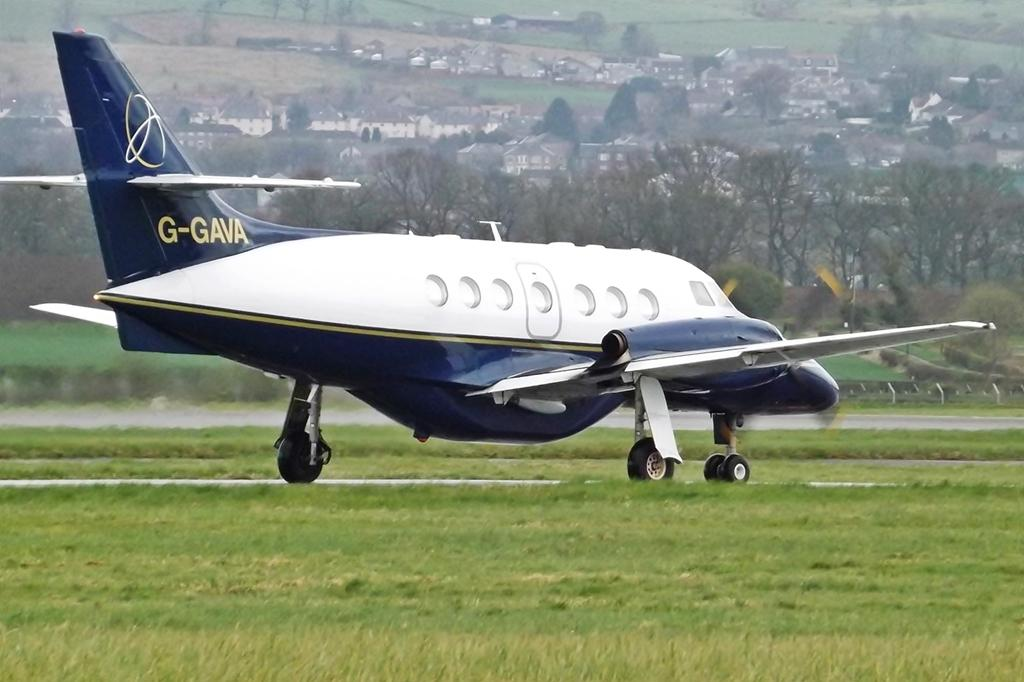<image>
Give a short and clear explanation of the subsequent image. Blue and white airplane that has G-GAVA on the tail about to take off. 